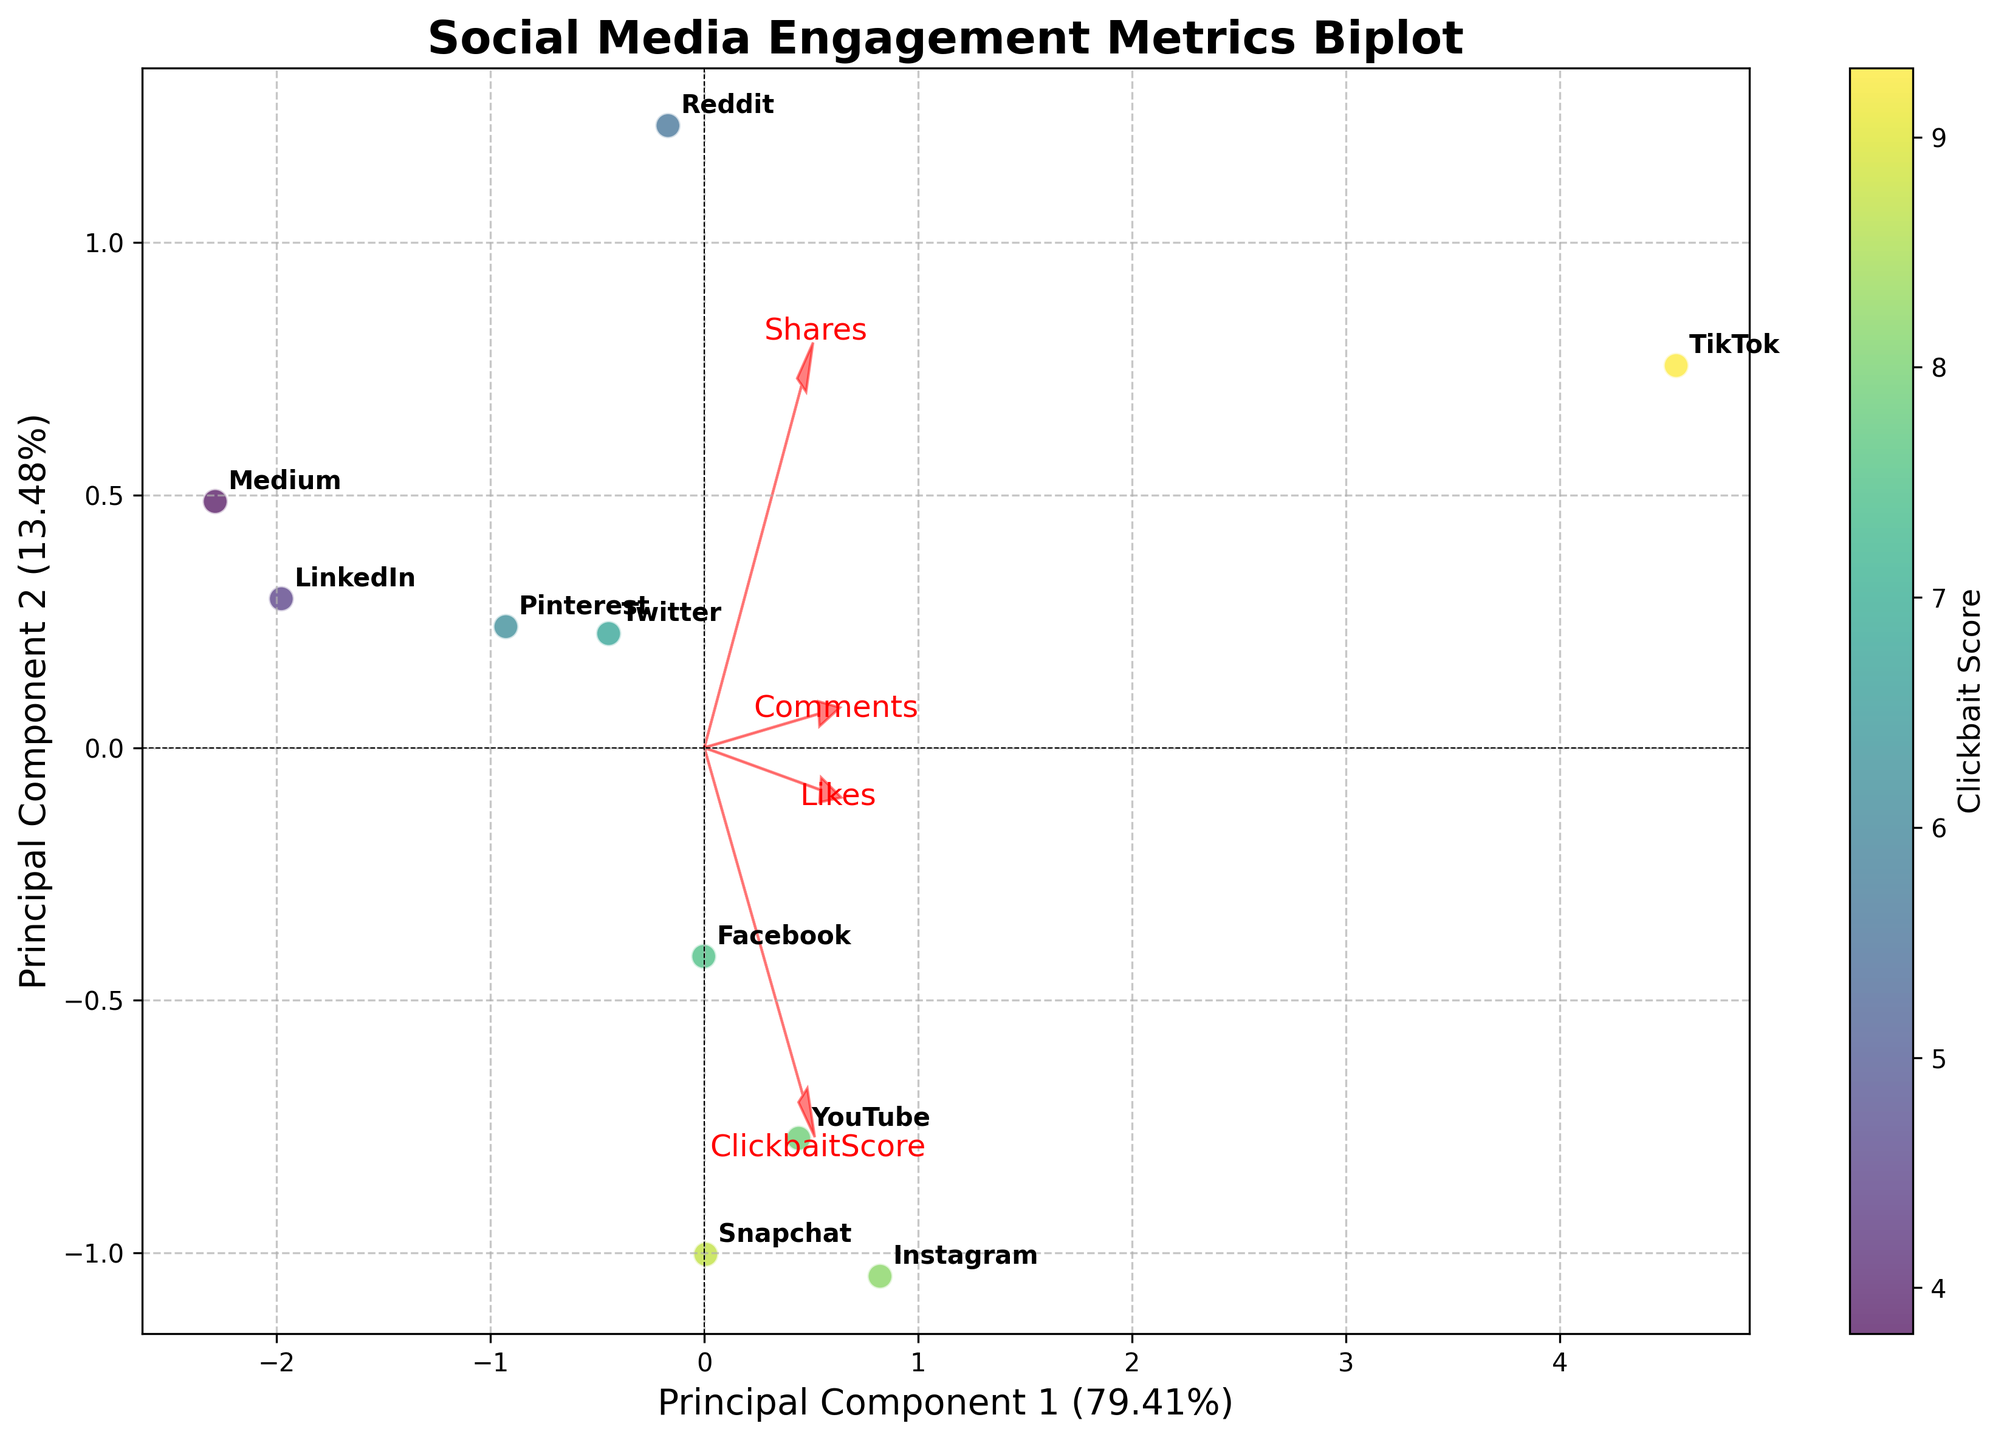What is the title of the biplot? The title of the biplot can be found at the top of the figure, which typically describes what the figure is about. In this case, it should read as "Social Media Engagement Metrics Biplot".
Answer: Social Media Engagement Metrics Biplot How many platforms are displayed in the biplot? To find the number of platforms, count the number of labeled data points in the plot. Each point corresponds to a distinct platform.
Answer: 10 Which platform has the highest Clickbait Score? The Clickbait Score is represented by the color gradient on the figure. The platform with the darkest color (highest score) would be the one with the highest Clickbait Score.
Answer: TikTok How do the arrow vectors indicate the relationship between features and principal components? The arrows represent the direction and magnitude of the relationship between the principal components and the original features. Longer arrows indicate higher influence, and the direction shows the correlation. Look at the length and angle of arrows to understand this relation.
Answer: By showing the direction and influence magnitude Which two platforms are most similar based on their positions in the biplot? To determine similarity, look for data points that are close to each other. The platforms whose points are nearest in the plot are considered most similar.
Answer: YouTube and Snapchat Which feature has the largest variance in this biplot? The length of the arrows indicates the variance explained by each feature. The arrow with the greatest length from the origin represents the feature with the largest variance.
Answer: ClickbaitScore Is there a platform that has high values in both Likes and Comments? To determine this, observe the direction of the arrows for Likes and Comments, and identify the platforms that fall in the positive quadrant corresponding to these directions.
Answer: Instagram What can you infer about LinkedIn's engagement metrics based on its position in the biplot? LinkedIn's position is indicated in the plot. By looking at its placement relative to the feature arrows, you can infer which metrics LinkedIn scores higher or lower on. It is far from the longer arrows which suggests lower engagement metrics.
Answer: Lower engagement metrics Which features are positively correlated according to the biplot? Features are positively correlated if their vectors point in the same direction or are close to each other. Look for arrows that are aligned or slightly diverged in the same direction.
Answer: Likes and Comments How much of the total variance is explained by the first principal component? The percentage of variance explained by each principal component is typically labeled on the x-axis and y-axis. Look for the label on the x-axis to find the variance percentage of the first component.
Answer: % (from the plot) 